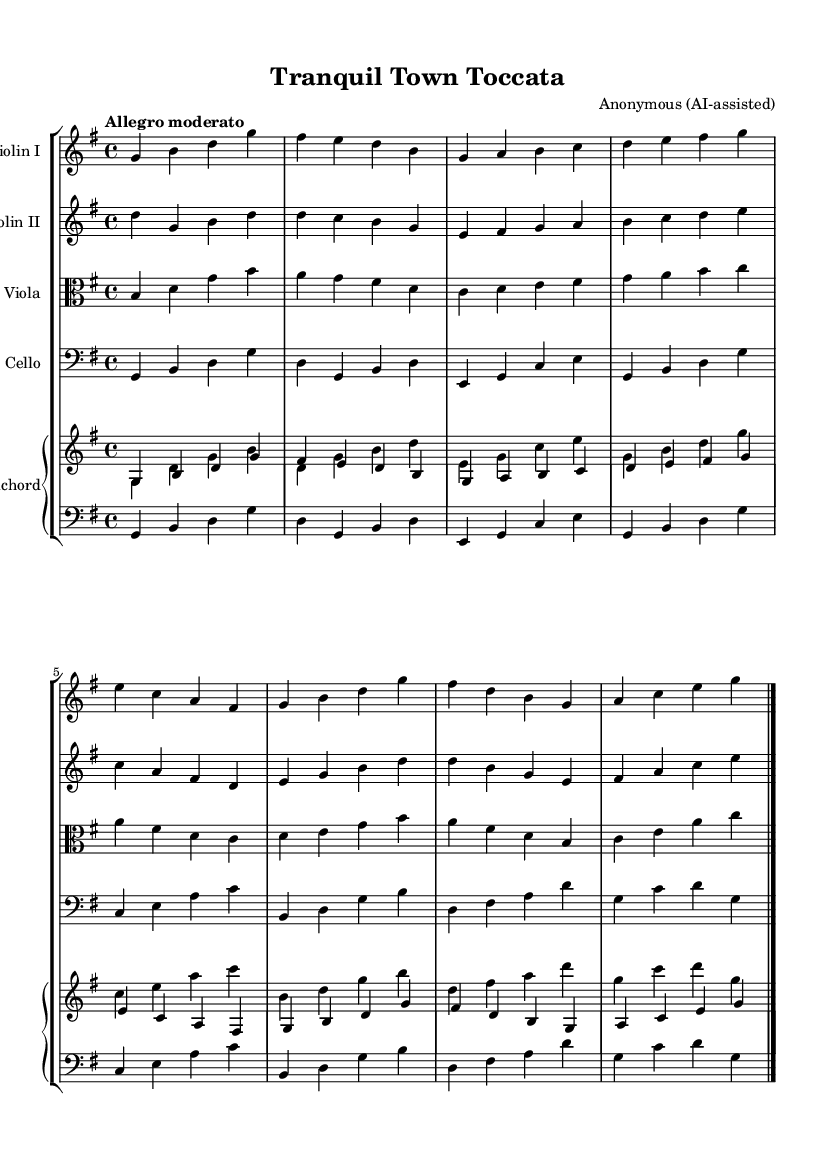What is the key signature of this music? The key signature is G major, which has one sharp (F#). This can be identified from the key signature indicated at the beginning of the score.
Answer: G major What is the time signature of this music? The time signature is 4/4, denoting four beats per measure. This is shown clearly at the start of the score following the key signature.
Answer: 4/4 What is the tempo marking of this piece? The tempo marking is "Allegro moderato." This indicates a moderately fast pace and is noted right after the time signature.
Answer: Allegro moderato How many instruments are featured in this piece? There are four distinct instruments: two violins, a viola, and a cello, plus a harpsichord. This can be seen in the staff groupings at the beginning of the score.
Answer: Four Which instrument plays the highest melodic line? The highest melodic line is played by Violin I, designated within the score at the top of the staff group.
Answer: Violin I What is the thematic character conveyed through the tempo and key, and how does it relate to small-town prosperity? The "Allegro moderato" tempo combined with the G major key creates a lively yet secure ambiance, reflecting a celebratory yet stable environment typical of small-town life. This relates to the idea of prosperity and security, echoing the positive impact of police presence as a protective measure for the community.
Answer: Celebratory stability How many measures does the piece consist of? The piece contains a total of 16 measures, which can be counted directly from the final bar lines in the score.
Answer: 16 